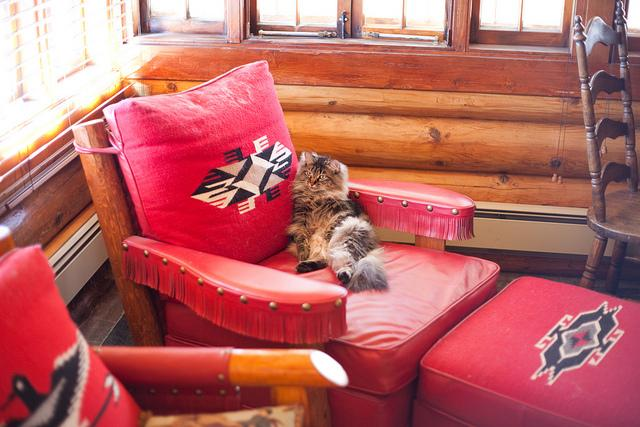What kind of walls are in this house? log 